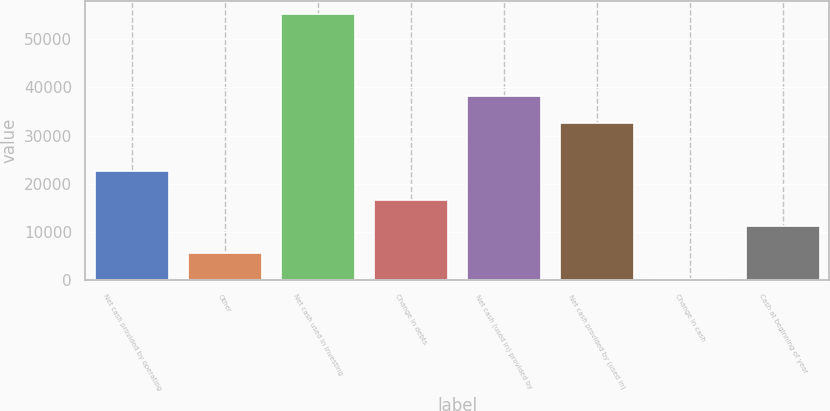Convert chart. <chart><loc_0><loc_0><loc_500><loc_500><bar_chart><fcel>Net cash provided by operating<fcel>Other<fcel>Net cash used in investing<fcel>Change in debts<fcel>Net cash (used in) provided by<fcel>Net cash provided by (used in)<fcel>Change in cash<fcel>Cash at beginning of year<nl><fcel>22660<fcel>5736.9<fcel>55182<fcel>16724.7<fcel>38137.9<fcel>32644<fcel>243<fcel>11230.8<nl></chart> 